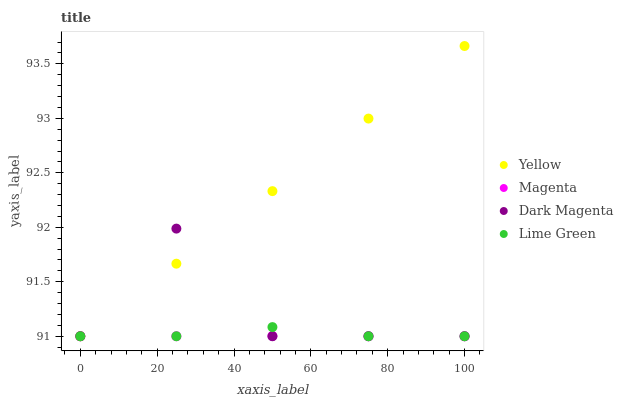Does Magenta have the minimum area under the curve?
Answer yes or no. Yes. Does Yellow have the maximum area under the curve?
Answer yes or no. Yes. Does Lime Green have the minimum area under the curve?
Answer yes or no. No. Does Lime Green have the maximum area under the curve?
Answer yes or no. No. Is Yellow the smoothest?
Answer yes or no. Yes. Is Dark Magenta the roughest?
Answer yes or no. Yes. Is Lime Green the smoothest?
Answer yes or no. No. Is Lime Green the roughest?
Answer yes or no. No. Does Magenta have the lowest value?
Answer yes or no. Yes. Does Yellow have the highest value?
Answer yes or no. Yes. Does Lime Green have the highest value?
Answer yes or no. No. Does Lime Green intersect Dark Magenta?
Answer yes or no. Yes. Is Lime Green less than Dark Magenta?
Answer yes or no. No. Is Lime Green greater than Dark Magenta?
Answer yes or no. No. 